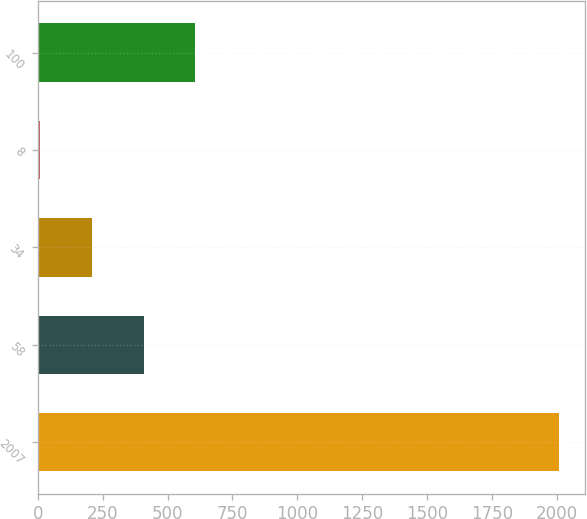Convert chart to OTSL. <chart><loc_0><loc_0><loc_500><loc_500><bar_chart><fcel>2007<fcel>58<fcel>34<fcel>8<fcel>100<nl><fcel>2006<fcel>407.6<fcel>207.8<fcel>8<fcel>607.4<nl></chart> 